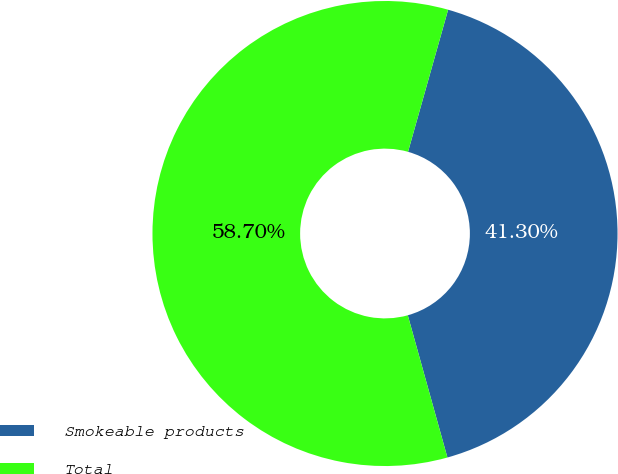<chart> <loc_0><loc_0><loc_500><loc_500><pie_chart><fcel>Smokeable products<fcel>Total<nl><fcel>41.3%<fcel>58.7%<nl></chart> 